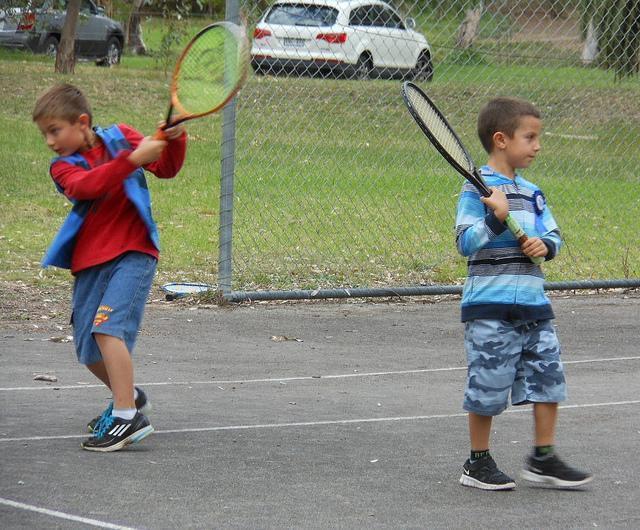What is the first name of the boy in the red's favorite hero?
Make your selection and explain in format: 'Answer: answer
Rationale: rationale.'
Options: Clark, tony, peter, bruce. Answer: clark.
Rationale: This is superman's first name. 